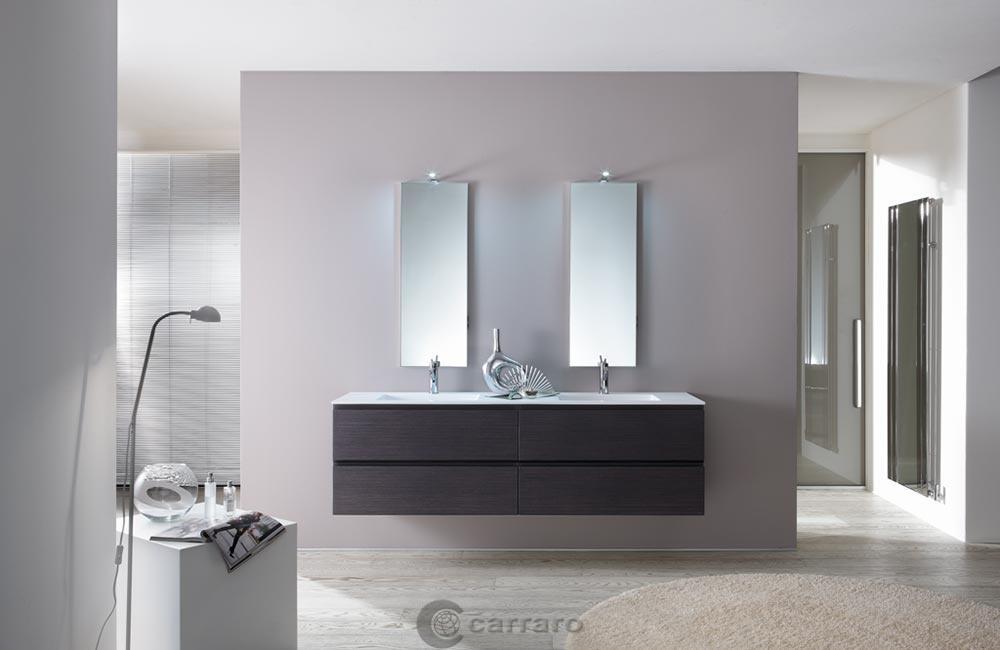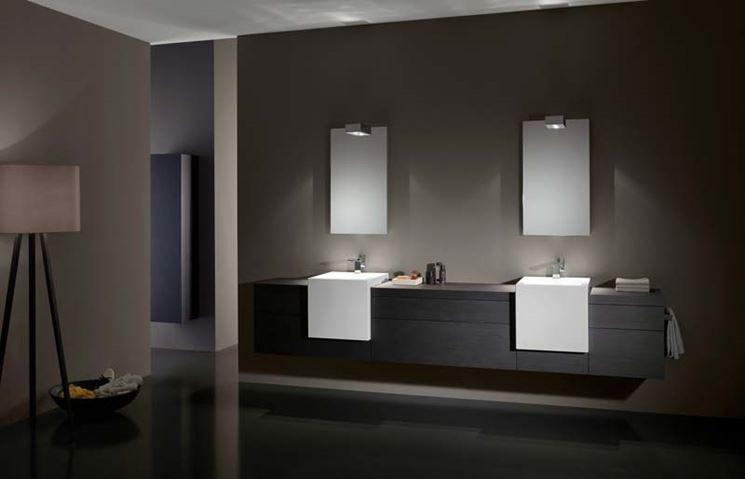The first image is the image on the left, the second image is the image on the right. Analyze the images presented: Is the assertion "At least one of the images has a window." valid? Answer yes or no. No. The first image is the image on the left, the second image is the image on the right. Assess this claim about the two images: "An image shows a rectangular mirror above a rectangular double sinks on a white wall-mounted vanity, and one image features wall-mounted spouts above two sinks.". Correct or not? Answer yes or no. No. 